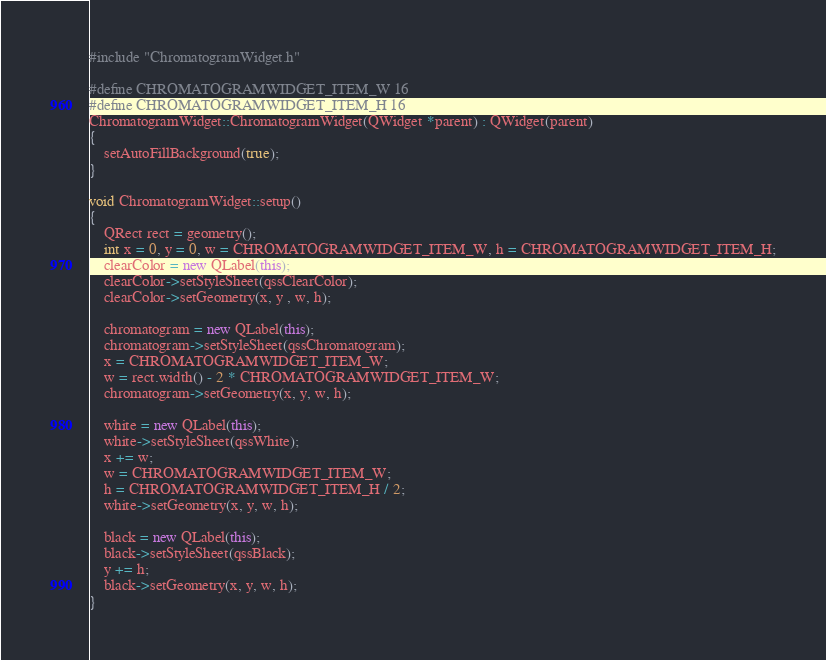<code> <loc_0><loc_0><loc_500><loc_500><_C++_>#include "ChromatogramWidget.h"

#define CHROMATOGRAMWIDGET_ITEM_W 16
#define CHROMATOGRAMWIDGET_ITEM_H 16
ChromatogramWidget::ChromatogramWidget(QWidget *parent) : QWidget(parent)
{
    setAutoFillBackground(true);
}

void ChromatogramWidget::setup()
{
    QRect rect = geometry();
    int x = 0, y = 0, w = CHROMATOGRAMWIDGET_ITEM_W, h = CHROMATOGRAMWIDGET_ITEM_H;
    clearColor = new QLabel(this);
    clearColor->setStyleSheet(qssClearColor);
    clearColor->setGeometry(x, y , w, h);

    chromatogram = new QLabel(this);
    chromatogram->setStyleSheet(qssChromatogram);
    x = CHROMATOGRAMWIDGET_ITEM_W;
    w = rect.width() - 2 * CHROMATOGRAMWIDGET_ITEM_W;
    chromatogram->setGeometry(x, y, w, h);

    white = new QLabel(this);
    white->setStyleSheet(qssWhite);
    x += w;
    w = CHROMATOGRAMWIDGET_ITEM_W;
    h = CHROMATOGRAMWIDGET_ITEM_H / 2;
    white->setGeometry(x, y, w, h);

    black = new QLabel(this);
    black->setStyleSheet(qssBlack);
    y += h;
    black->setGeometry(x, y, w, h);
}
</code> 